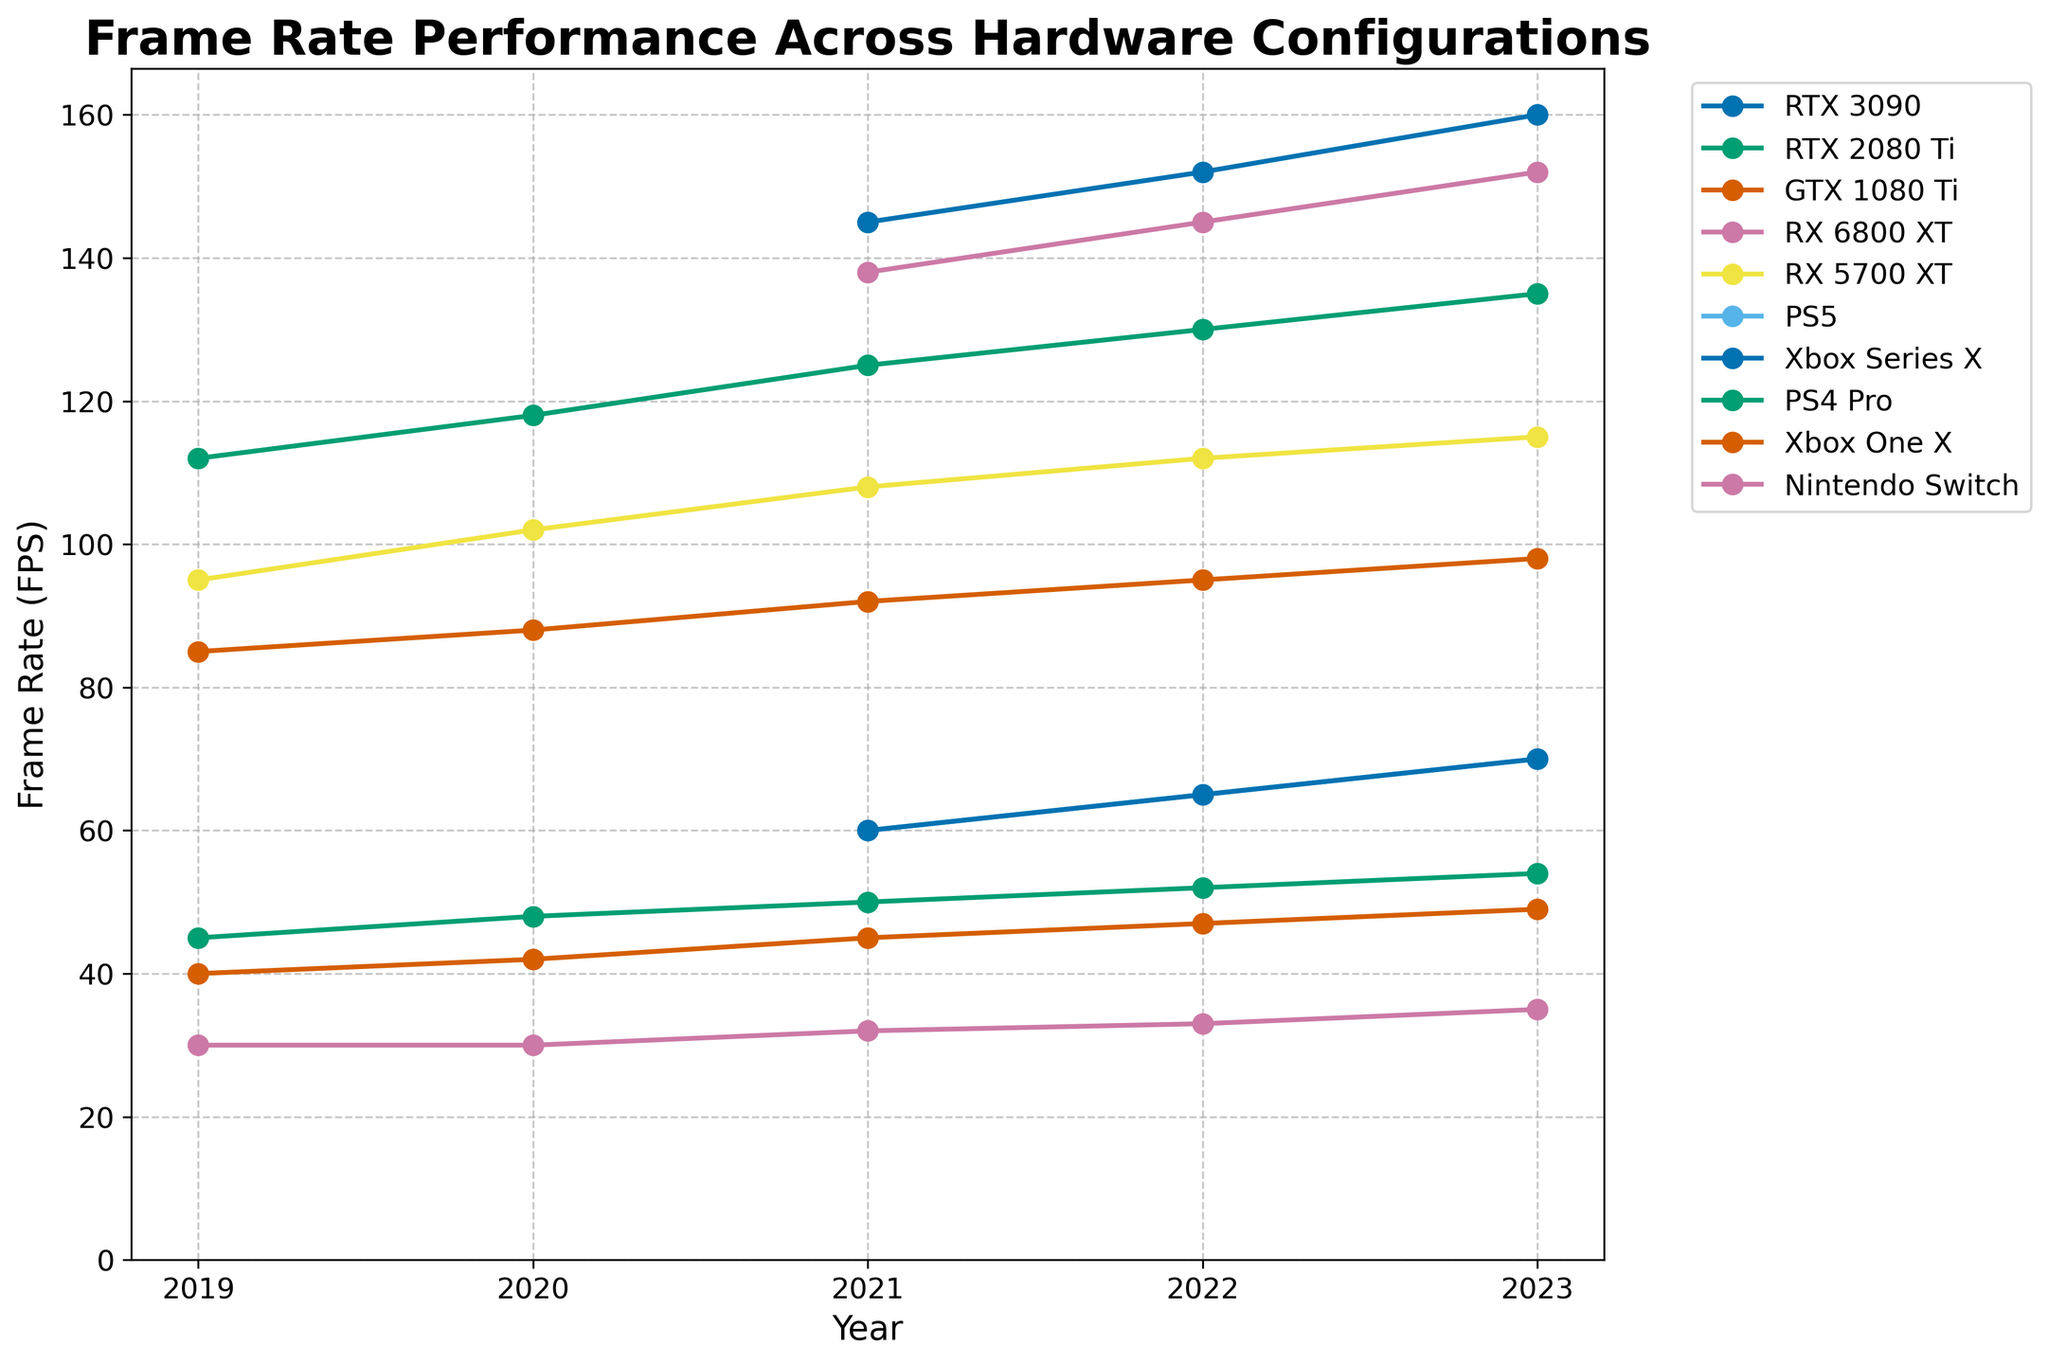Which hardware configuration had the highest frame rate in 2023, and what was the value? Look for the highest point in the 2023 column. RTX 3090 has the highest frame rate with 160 FPS.
Answer: RTX 3090 with 160 FPS What is the frame rate trend for the Nintendo Switch from 2019 to 2023? Observe the data points for the Nintendo Switch from 2019 to 2023; it increased gradually from 30 FPS in 2019 to 35 FPS in 2023.
Answer: Increasing trend from 30 FPS to 35 FPS What is the difference in frame rate between the PS5 and the PS4 Pro in 2022? Find the frame rates for PS5 and PS4 Pro in the year 2022. Subtract the frame rate of PS4 Pro (52 FPS) from PS5 (65 FPS): 65 - 52 = 13 FPS.
Answer: 13 FPS Which hardware configurations did not exist before 2021? Identify the hardware configurations marked as "N/A" before 2021. RTX 3090, RX 6800 XT, PS5, and Xbox Series X did not have data before 2021.
Answer: RTX 3090, RX 6800 XT, PS5, Xbox Series X In what year did the GTX 1080 Ti have the highest frame rate, and what was the value? Look for the maximum value in the GTX 1080 Ti row. It reached its highest frame rate in 2023 with 98 FPS.
Answer: 2023 with 98 FPS Which hardware achieved over 100 FPS consistently from 2019 to 2023? Check for hardware configurations maintaining over 100 FPS in all available years. RTX 2080 Ti is the consistent performer with over 100 FPS.
Answer: RTX 2080 Ti How does the frame rate of the RX 5700 XT in 2020 compare to its frame rate in 2023? Find the values for RX 5700 XT in 2020 and 2023. The frame rate increased from 102 FPS in 2020 to 115 FPS in 2023.
Answer: Increased from 102 FPS to 115 FPS What is the average frame rate for the PS4 Pro from 2019 to 2023? Calculate the average of the frame rates for PS4 Pro: (45 + 48 + 50 + 52 + 54) / 5 = 49.8 FPS.
Answer: 49.8 FPS Which hardware configuration has the consistently lowest frame rate, and what are the values from 2019 to 2023? Identify the lowest values in each year. The Nintendo Switch consistently has the lowest frame rates: 30, 30, 32, 33, 35 FPS.
Answer: Nintendo Switch with values 30, 30, 32, 33, 35 FPS 